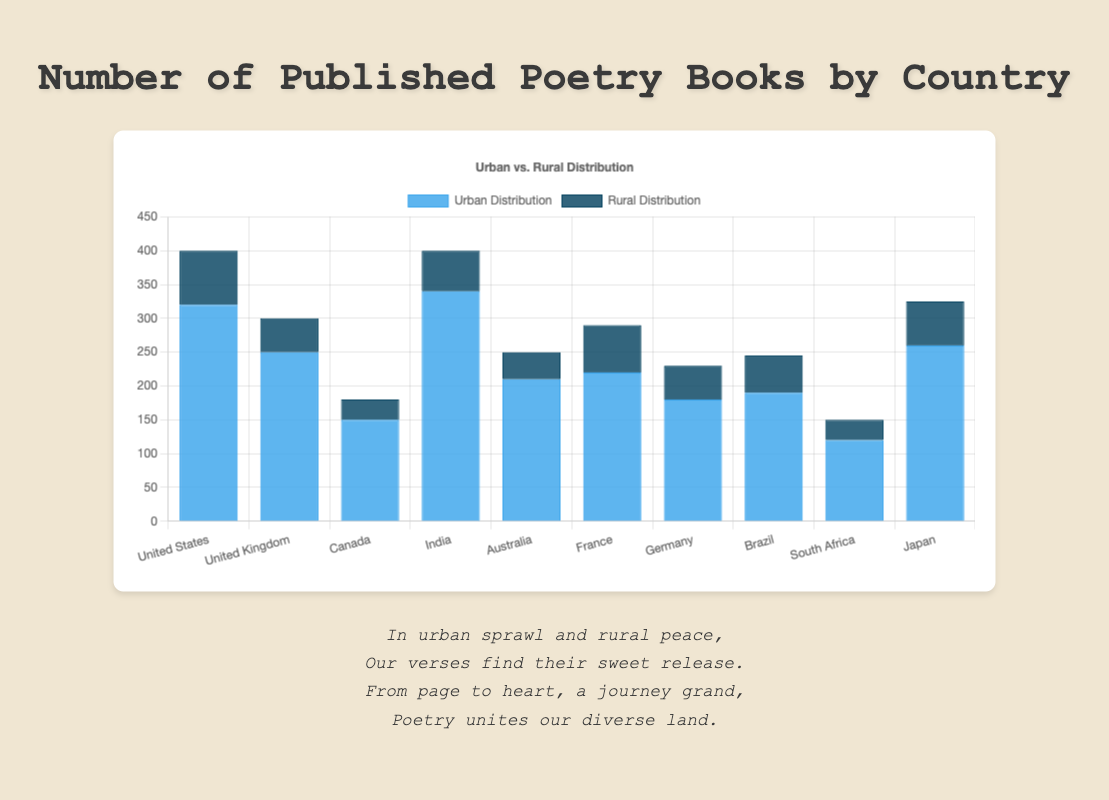Which country has the highest number of published poetry books in urban areas? To determine this, look at the 'Urban Distribution' bars for each country. The bar for India is the highest with a value of 340.
Answer: India What is the total number of published poetry books in rural areas for Canada and Brazil combined? Sum the 'Rural Distribution' values for Canada and Brazil: 30 (Canada) + 55 (Brazil) = 85.
Answer: 85 Which two countries have the smallest difference between urban and rural poetry book distributions? Calculate the differences for each country and identify the smallest two: United Kingdom (200), Japan (195) have the smallest differences.
Answer: United Kingdom and Japan How many more poetry books are published in urban areas than in rural areas in Australia? Subtract the 'Rural Distribution' value from the 'Urban Distribution' value for Australia: 210 - 40 = 170.
Answer: 170 Which country has the lowest number of published poetry books in rural areas? Find the smallest value in the 'Rural Distribution' list: Canada with 30.
Answer: Canada What is the average number of published poetry books in urban areas across all countries? Sum all 'Urban Distribution' values and divide by the number of countries: (320 + 250 + 150 + 340 + 210 + 220 + 180 + 190 + 120 + 260) / 10 = 2240 / 10 = 224.
Answer: 224 Which country has a higher rural distribution of poetry books: France or Germany? Compare the 'Rural Distribution' values for France (70) and Germany (50): France has a higher value.
Answer: France What is the total number of published poetry books in South Africa across both urban and rural areas? Sum the 'Urban Distribution' and 'Rural Distribution' values for South Africa: 120 + 30 = 150.
Answer: 150 How much more significant is the urban distribution of poetry books in the United States than in Brazil? Subtract the 'Urban Distribution' value of Brazil from that of the United States: 320 - 190 = 130.
Answer: 130 